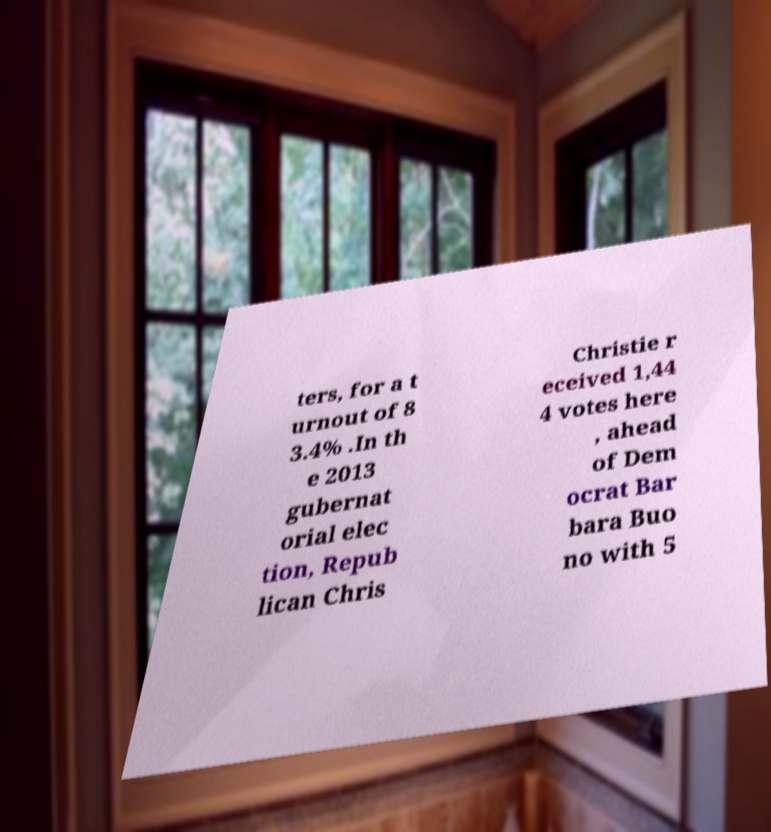I need the written content from this picture converted into text. Can you do that? ters, for a t urnout of 8 3.4% .In th e 2013 gubernat orial elec tion, Repub lican Chris Christie r eceived 1,44 4 votes here , ahead of Dem ocrat Bar bara Buo no with 5 